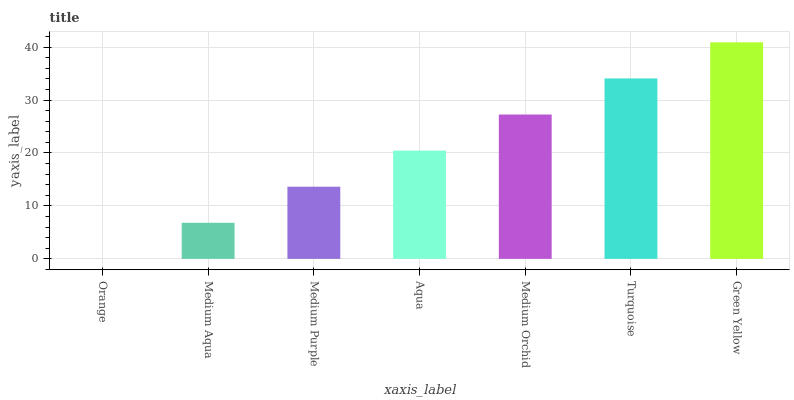Is Medium Aqua the minimum?
Answer yes or no. No. Is Medium Aqua the maximum?
Answer yes or no. No. Is Medium Aqua greater than Orange?
Answer yes or no. Yes. Is Orange less than Medium Aqua?
Answer yes or no. Yes. Is Orange greater than Medium Aqua?
Answer yes or no. No. Is Medium Aqua less than Orange?
Answer yes or no. No. Is Aqua the high median?
Answer yes or no. Yes. Is Aqua the low median?
Answer yes or no. Yes. Is Orange the high median?
Answer yes or no. No. Is Medium Purple the low median?
Answer yes or no. No. 